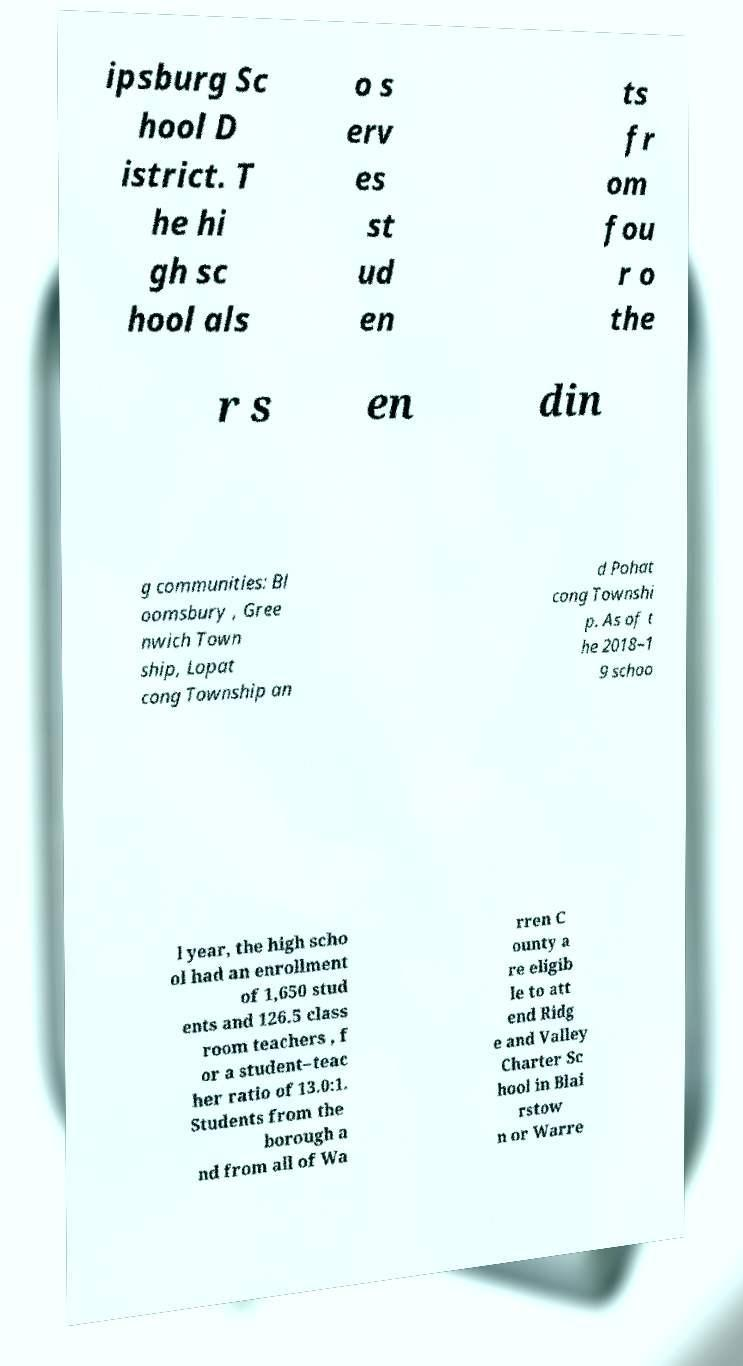Could you extract and type out the text from this image? ipsburg Sc hool D istrict. T he hi gh sc hool als o s erv es st ud en ts fr om fou r o the r s en din g communities: Bl oomsbury , Gree nwich Town ship, Lopat cong Township an d Pohat cong Townshi p. As of t he 2018–1 9 schoo l year, the high scho ol had an enrollment of 1,650 stud ents and 126.5 class room teachers , f or a student–teac her ratio of 13.0:1. Students from the borough a nd from all of Wa rren C ounty a re eligib le to att end Ridg e and Valley Charter Sc hool in Blai rstow n or Warre 